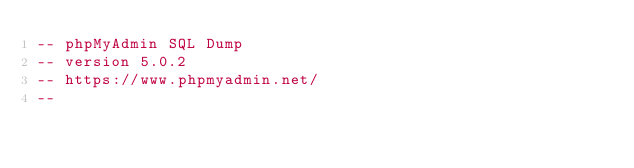Convert code to text. <code><loc_0><loc_0><loc_500><loc_500><_SQL_>-- phpMyAdmin SQL Dump
-- version 5.0.2
-- https://www.phpmyadmin.net/
--</code> 